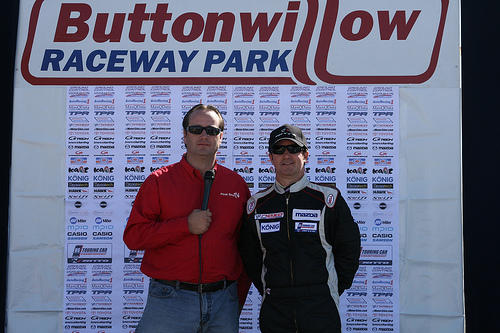<image>
Can you confirm if the man is behind the man? No. The man is not behind the man. From this viewpoint, the man appears to be positioned elsewhere in the scene. 